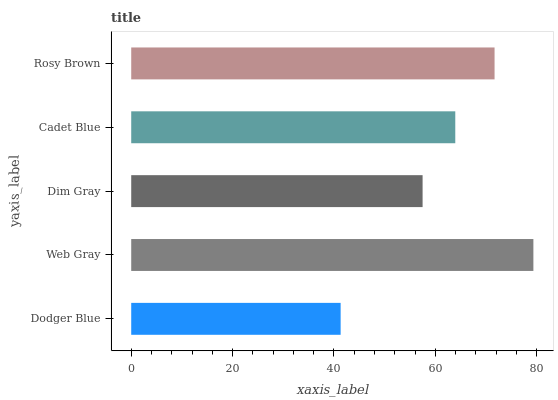Is Dodger Blue the minimum?
Answer yes or no. Yes. Is Web Gray the maximum?
Answer yes or no. Yes. Is Dim Gray the minimum?
Answer yes or no. No. Is Dim Gray the maximum?
Answer yes or no. No. Is Web Gray greater than Dim Gray?
Answer yes or no. Yes. Is Dim Gray less than Web Gray?
Answer yes or no. Yes. Is Dim Gray greater than Web Gray?
Answer yes or no. No. Is Web Gray less than Dim Gray?
Answer yes or no. No. Is Cadet Blue the high median?
Answer yes or no. Yes. Is Cadet Blue the low median?
Answer yes or no. Yes. Is Dodger Blue the high median?
Answer yes or no. No. Is Rosy Brown the low median?
Answer yes or no. No. 